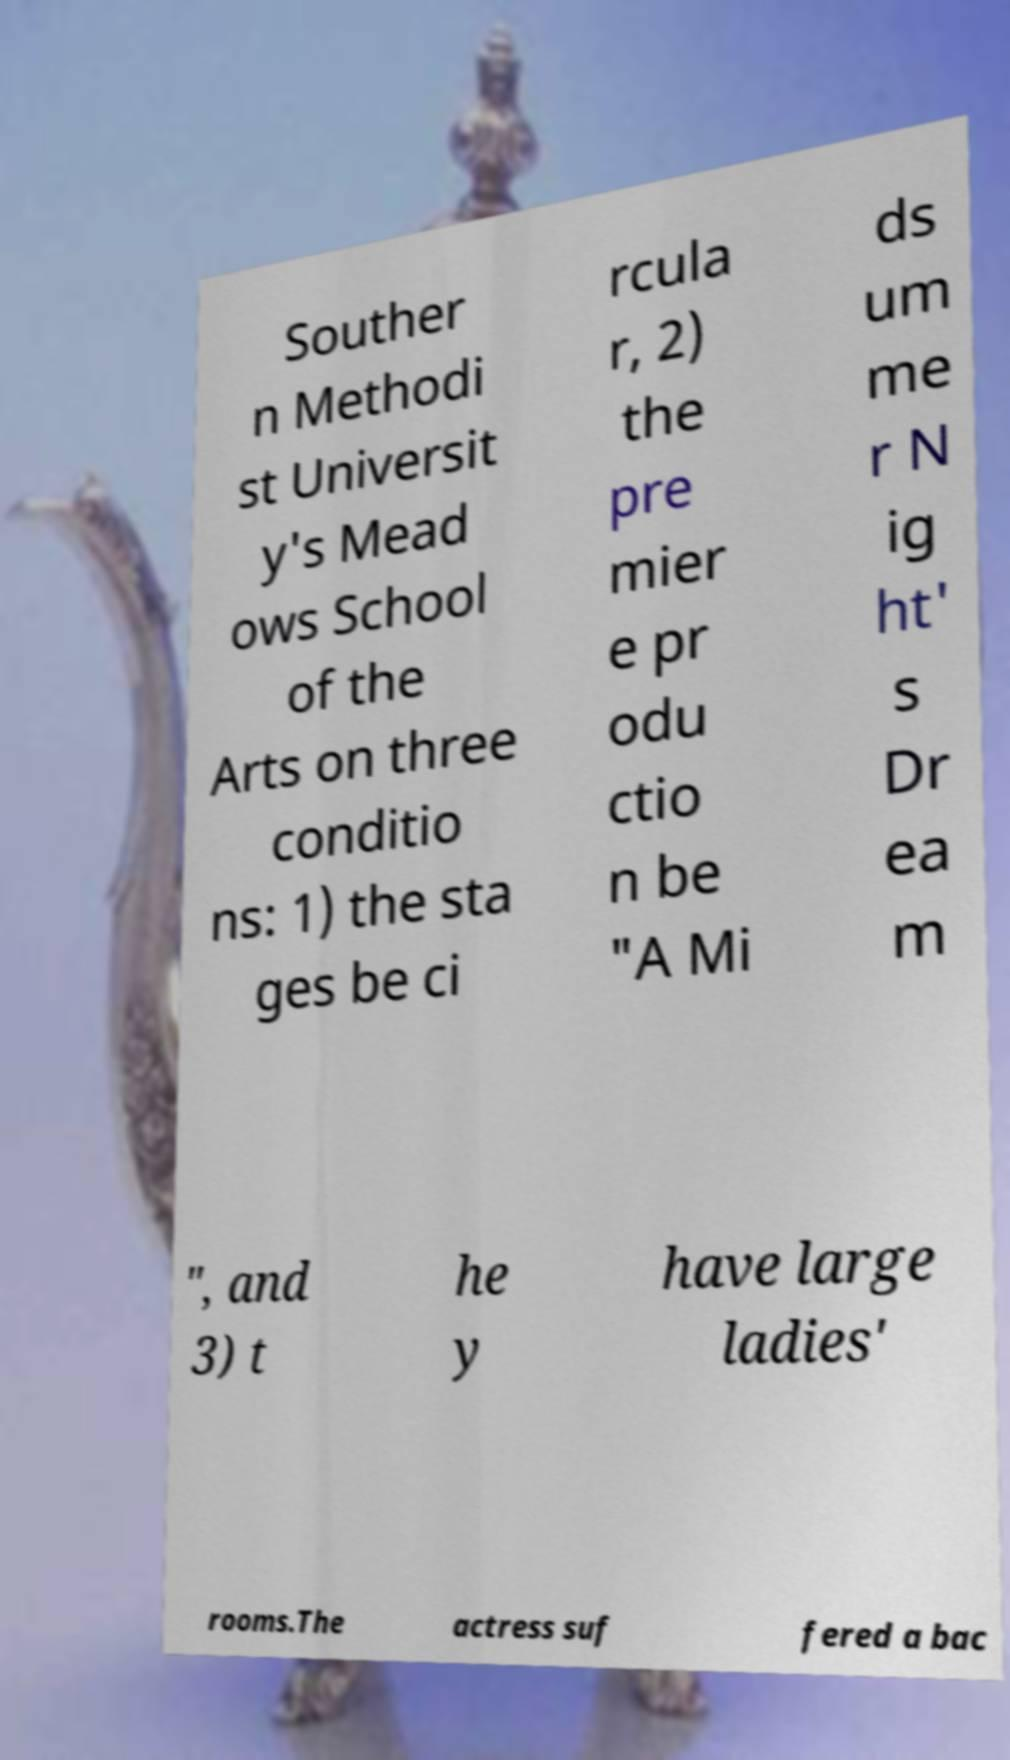Please identify and transcribe the text found in this image. Souther n Methodi st Universit y's Mead ows School of the Arts on three conditio ns: 1) the sta ges be ci rcula r, 2) the pre mier e pr odu ctio n be "A Mi ds um me r N ig ht' s Dr ea m ", and 3) t he y have large ladies' rooms.The actress suf fered a bac 